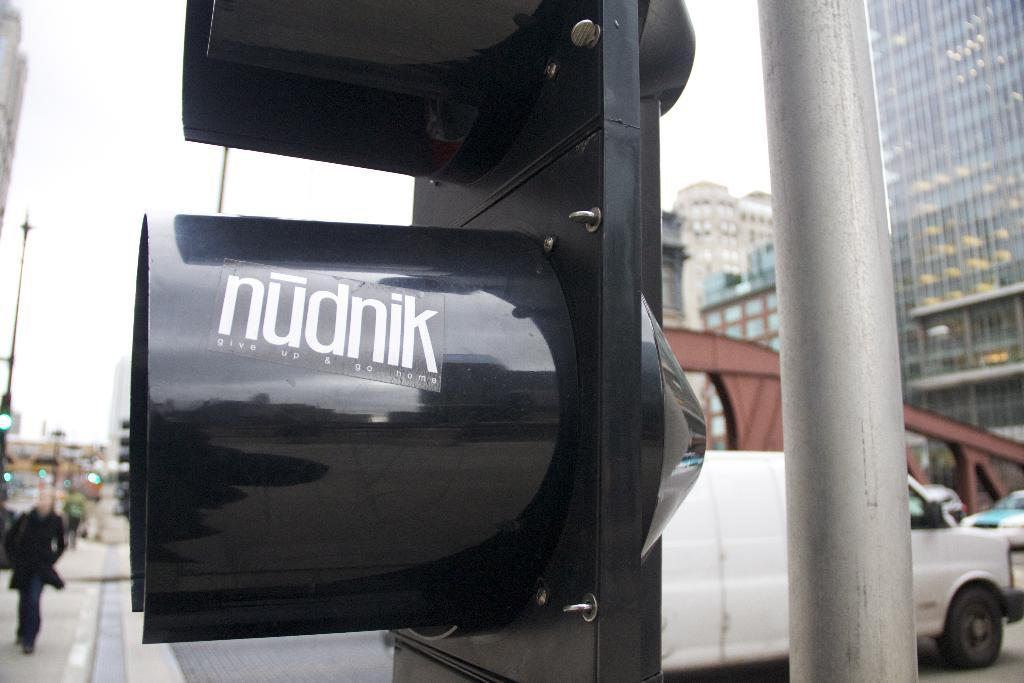<image>
Write a terse but informative summary of the picture. A sign on a downtown street with the name nudnik. 